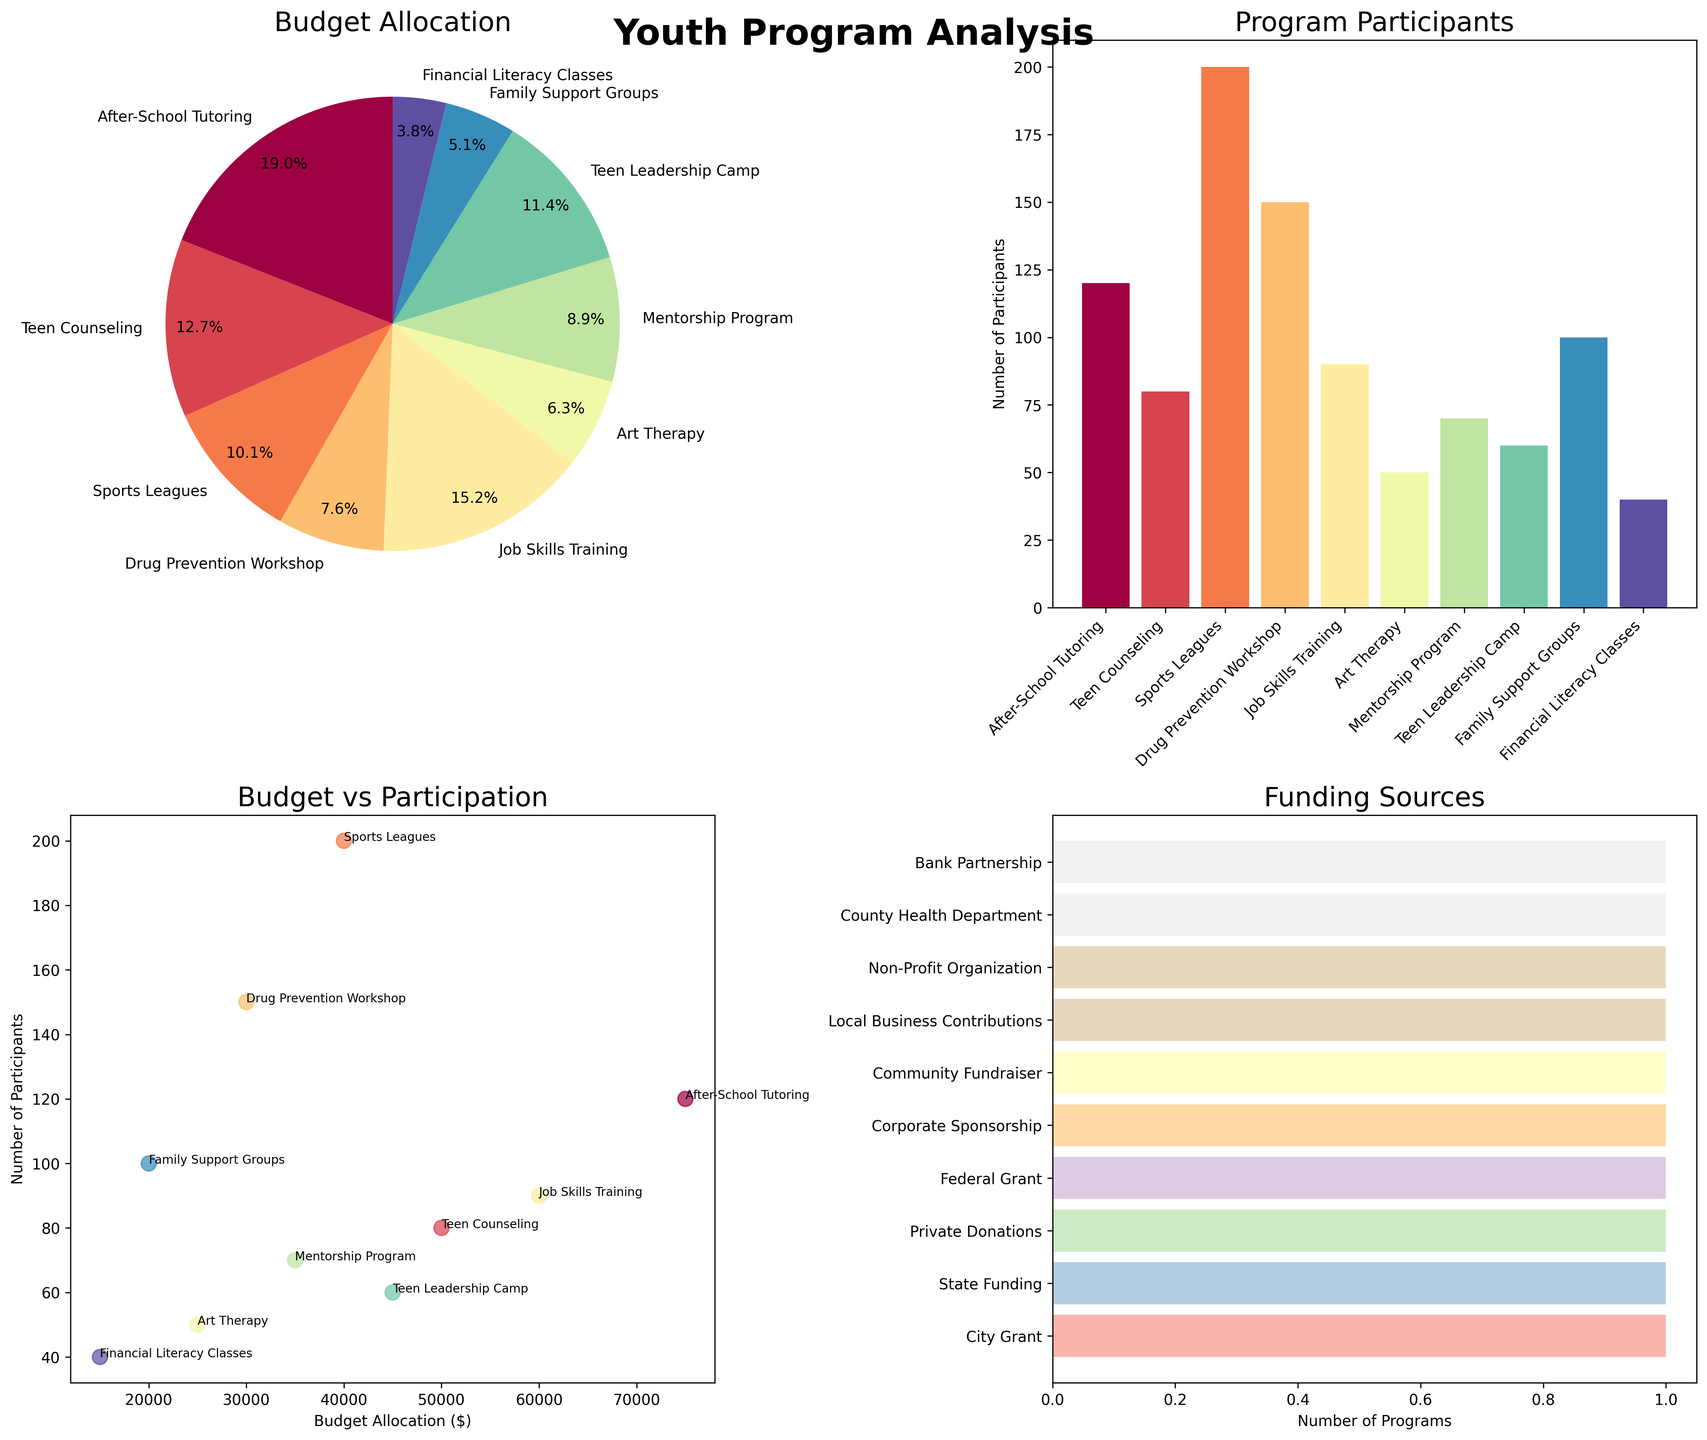Which program received the highest budget allocation? By looking at the pie chart labeled "Budget Allocation," we can see the relative size of each slice of the pie. The "After-School Tutoring" program has the largest slice, indicating it received the highest budget allocation.
Answer: After-School Tutoring How many participants are involved in the Sports Leagues program? The bar chart labeled "Program Participants" shows the number of participants for each program. We can see that the bar for "Sports Leagues" reaches up to 200 participants.
Answer: 200 What is the total number of programs funded by City Grant and State Funding combined? The horizontal bar chart labeled "Funding Sources" shows the number of programs funded by each source. "City Grant" funds 1 program and "State Funding" also funds 1 program. Adding them together gives a total of 2 programs.
Answer: 2 Which program has the lowest number of participants, and what is its budget allocation? From the bar chart labeled "Program Participants," the "Financial Literacy Classes" has the shortest bar with 40 participants. Referring to the pie chart, we see that its slice is smaller compared to others, corresponding to a budget of $15,000.
Answer: Financial Literacy Classes, $15,000 How does the budget allocation for Job Skills Training compare with the Teen Leadership Camp? We need to compare the budget allocation values for both programs. Job Skills Training has a budget of $60,000, and Teen Leadership Camp has a budget of $45,000. Therefore, Job Skills Training has a higher budget allocation than Teen Leadership Camp.
Answer: Job Skills Training has a higher budget Is there a general correlation between budget allocation and the number of participants? To determine this, we look at the scatter plot labeled "Budget vs Participation." We observe the dots. While high budget programs tend to have many participants in some cases, there are exceptions, indicating no strong correlation.
Answer: No strong correlation What percentage of the budget is allocated to the After-School Tutoring program? In the pie chart labeled "Budget Allocation," the After-School Tutoring program slice indicates a percentage. Referring closely, it is noted at around 27.3%.
Answer: 27.3% Which program funded by a Federal Grant, and how many participants does it have? From the horizontal bar chart, we see one program funded by a Federal Grant. Referring to the bar chart of participants, it shows "Drug Prevention Workshop" has 150 participants.
Answer: Drug Prevention Workshop, 150 